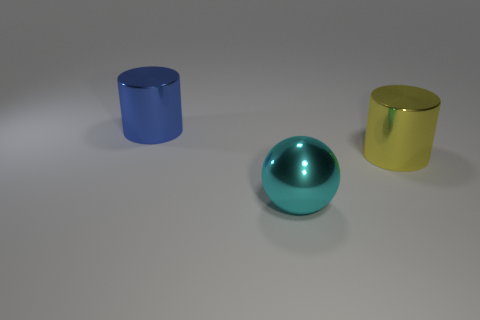Add 1 large yellow things. How many objects exist? 4 Subtract all cylinders. How many objects are left? 1 Subtract 0 purple cubes. How many objects are left? 3 Subtract all large yellow cylinders. Subtract all blue metal cylinders. How many objects are left? 1 Add 1 large yellow metal cylinders. How many large yellow metal cylinders are left? 2 Add 3 big cyan metal objects. How many big cyan metal objects exist? 4 